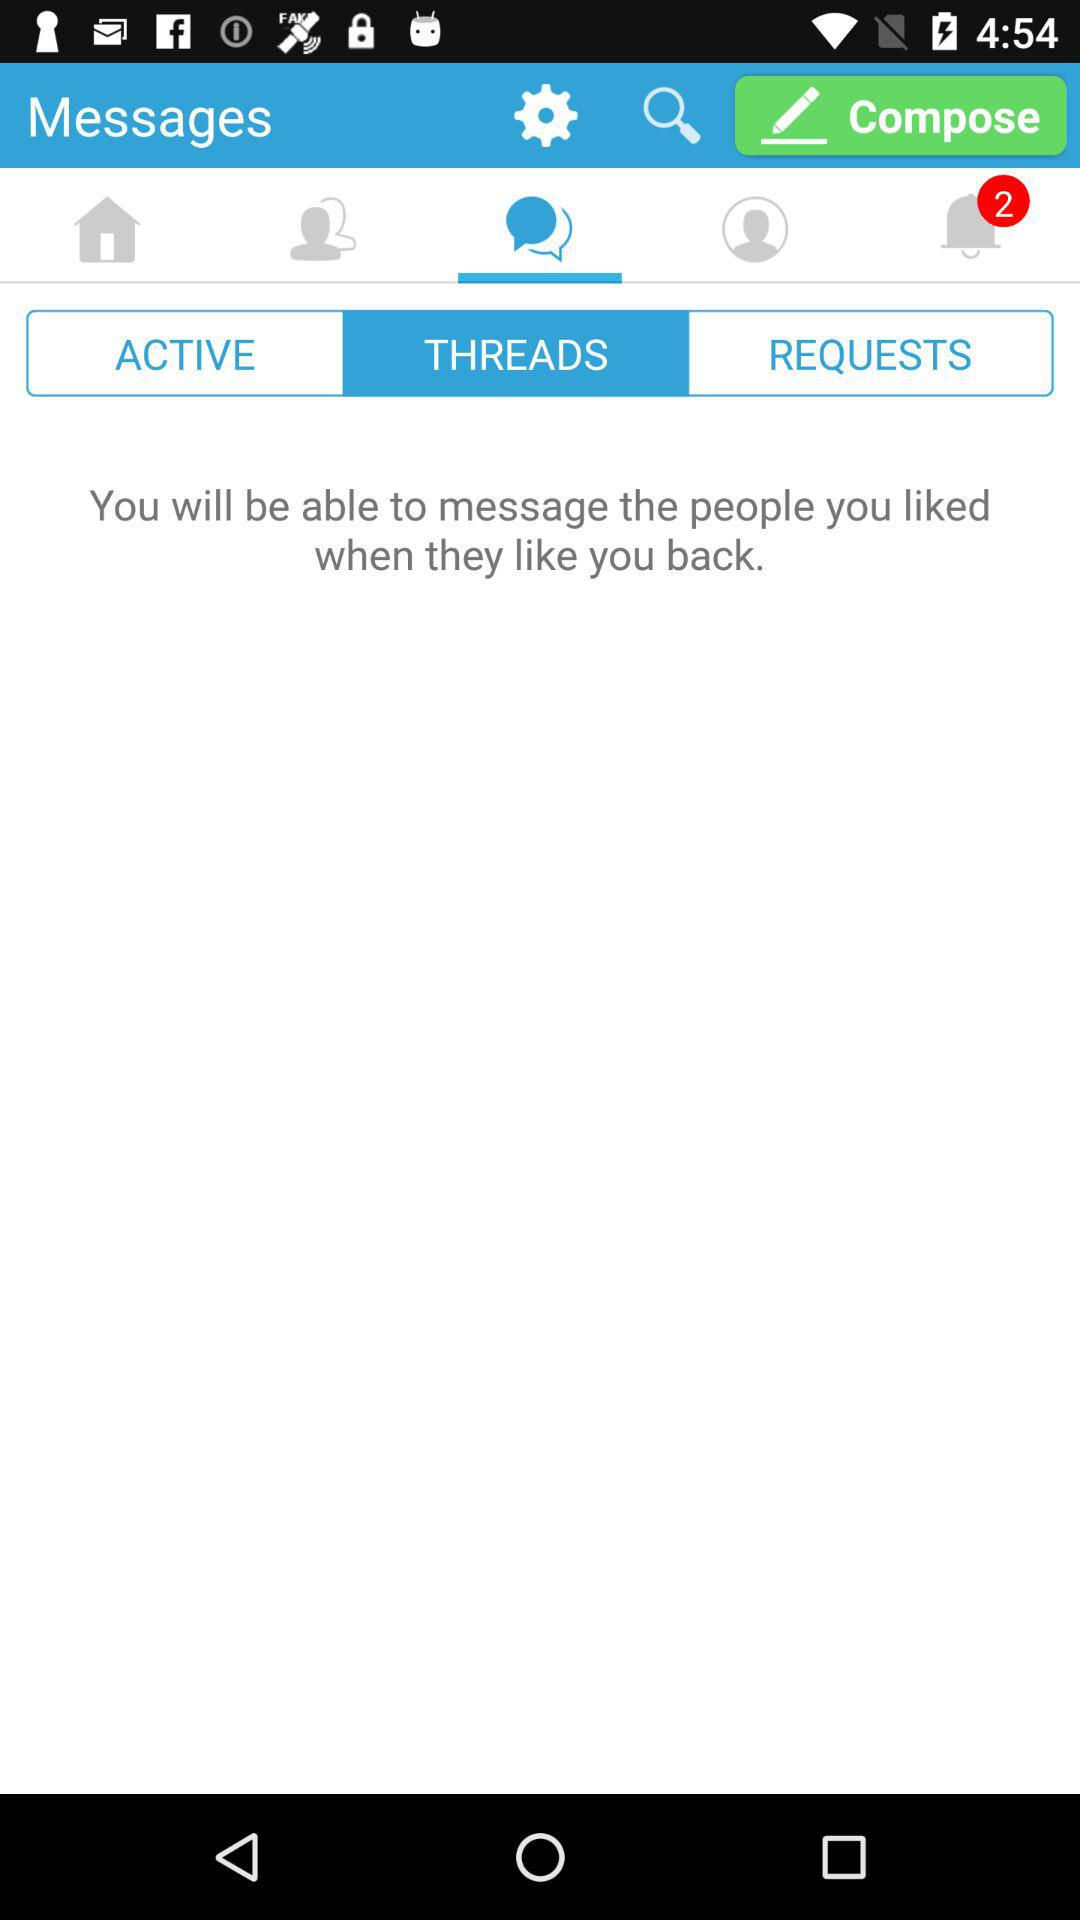How many unread notifications are there? There are 2 unread notifications. 